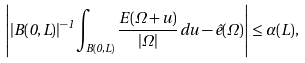Convert formula to latex. <formula><loc_0><loc_0><loc_500><loc_500>\left | | B ( 0 , L ) | ^ { - 1 } \int _ { B ( 0 , L ) } \frac { E ( \Omega + u ) } { | \Omega | } \, d u - \hat { e } ( \Omega ) \right | \leq \alpha ( L ) ,</formula> 